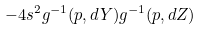Convert formula to latex. <formula><loc_0><loc_0><loc_500><loc_500>- 4 s ^ { 2 } g ^ { - 1 } ( p , d Y ) g ^ { - 1 } ( p , d Z )</formula> 